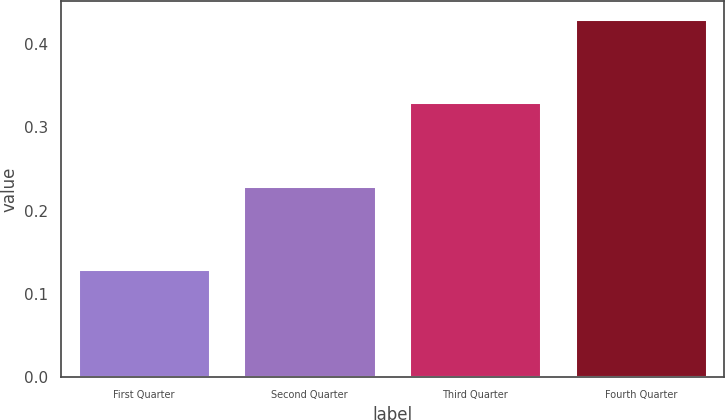Convert chart to OTSL. <chart><loc_0><loc_0><loc_500><loc_500><bar_chart><fcel>First Quarter<fcel>Second Quarter<fcel>Third Quarter<fcel>Fourth Quarter<nl><fcel>0.13<fcel>0.23<fcel>0.33<fcel>0.43<nl></chart> 